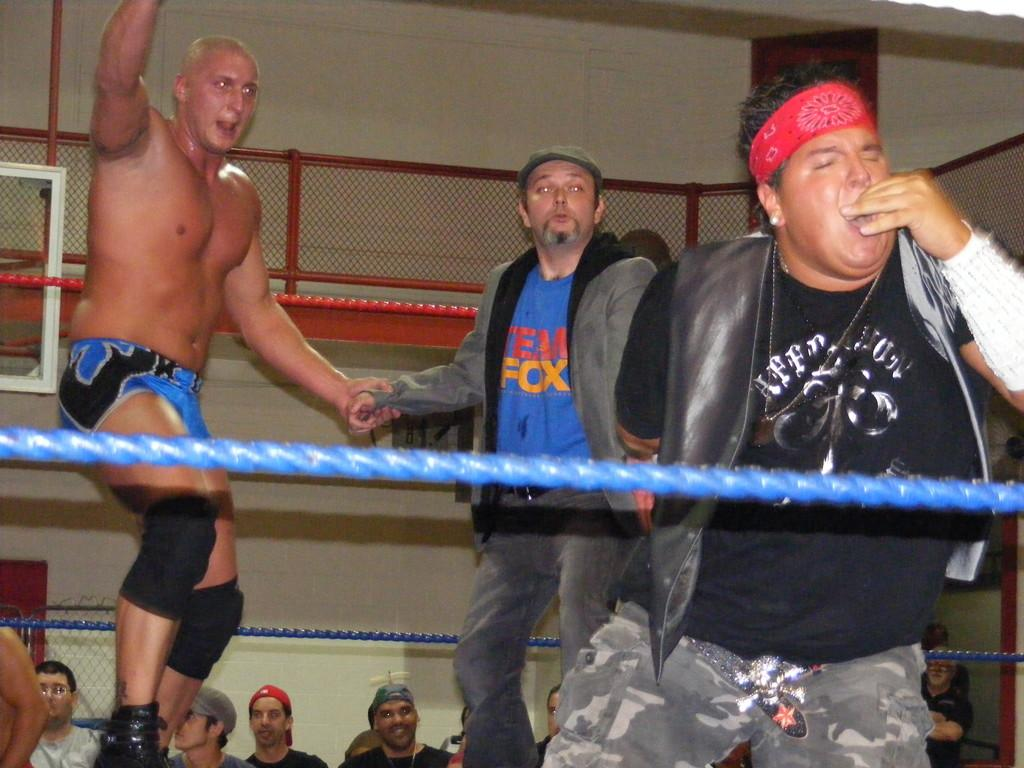<image>
Relay a brief, clear account of the picture shown. A man in a blue shirt in a wrestling ring that says Team Fox 